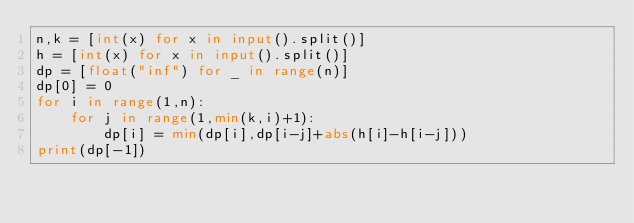Convert code to text. <code><loc_0><loc_0><loc_500><loc_500><_Python_>n,k = [int(x) for x in input().split()]
h = [int(x) for x in input().split()]
dp = [float("inf") for _ in range(n)]
dp[0] = 0
for i in range(1,n):
    for j in range(1,min(k,i)+1):
        dp[i] = min(dp[i],dp[i-j]+abs(h[i]-h[i-j]))
print(dp[-1])</code> 